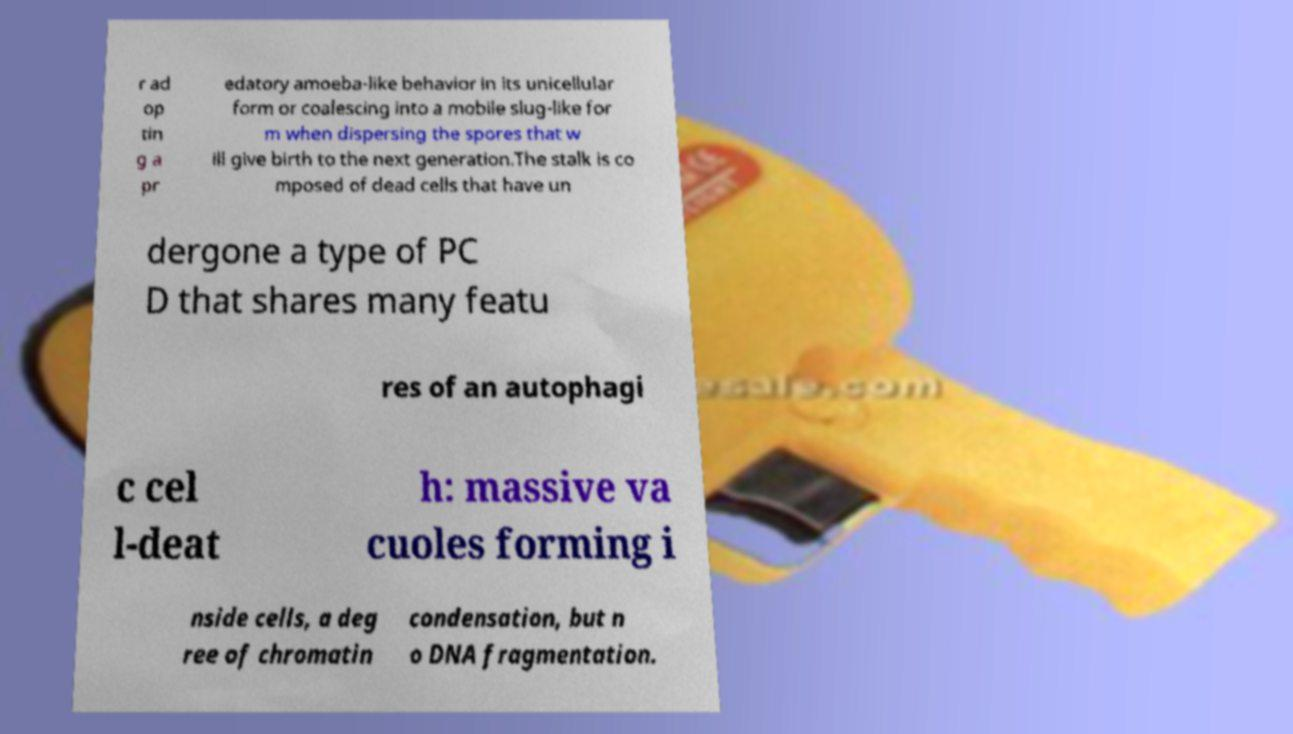There's text embedded in this image that I need extracted. Can you transcribe it verbatim? r ad op tin g a pr edatory amoeba-like behavior in its unicellular form or coalescing into a mobile slug-like for m when dispersing the spores that w ill give birth to the next generation.The stalk is co mposed of dead cells that have un dergone a type of PC D that shares many featu res of an autophagi c cel l-deat h: massive va cuoles forming i nside cells, a deg ree of chromatin condensation, but n o DNA fragmentation. 